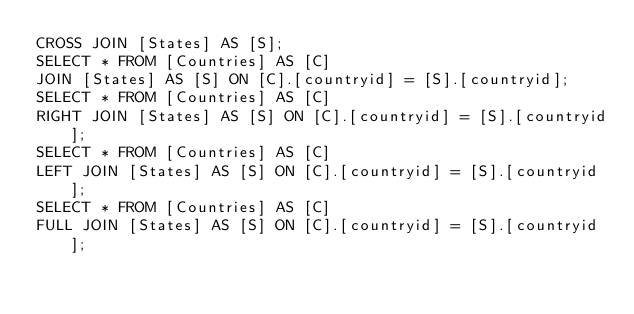<code> <loc_0><loc_0><loc_500><loc_500><_SQL_>CROSS JOIN [States] AS [S];
SELECT * FROM [Countries] AS [C]
JOIN [States] AS [S] ON [C].[countryid] = [S].[countryid];
SELECT * FROM [Countries] AS [C]
RIGHT JOIN [States] AS [S] ON [C].[countryid] = [S].[countryid];
SELECT * FROM [Countries] AS [C]
LEFT JOIN [States] AS [S] ON [C].[countryid] = [S].[countryid];
SELECT * FROM [Countries] AS [C]
FULL JOIN [States] AS [S] ON [C].[countryid] = [S].[countryid];</code> 